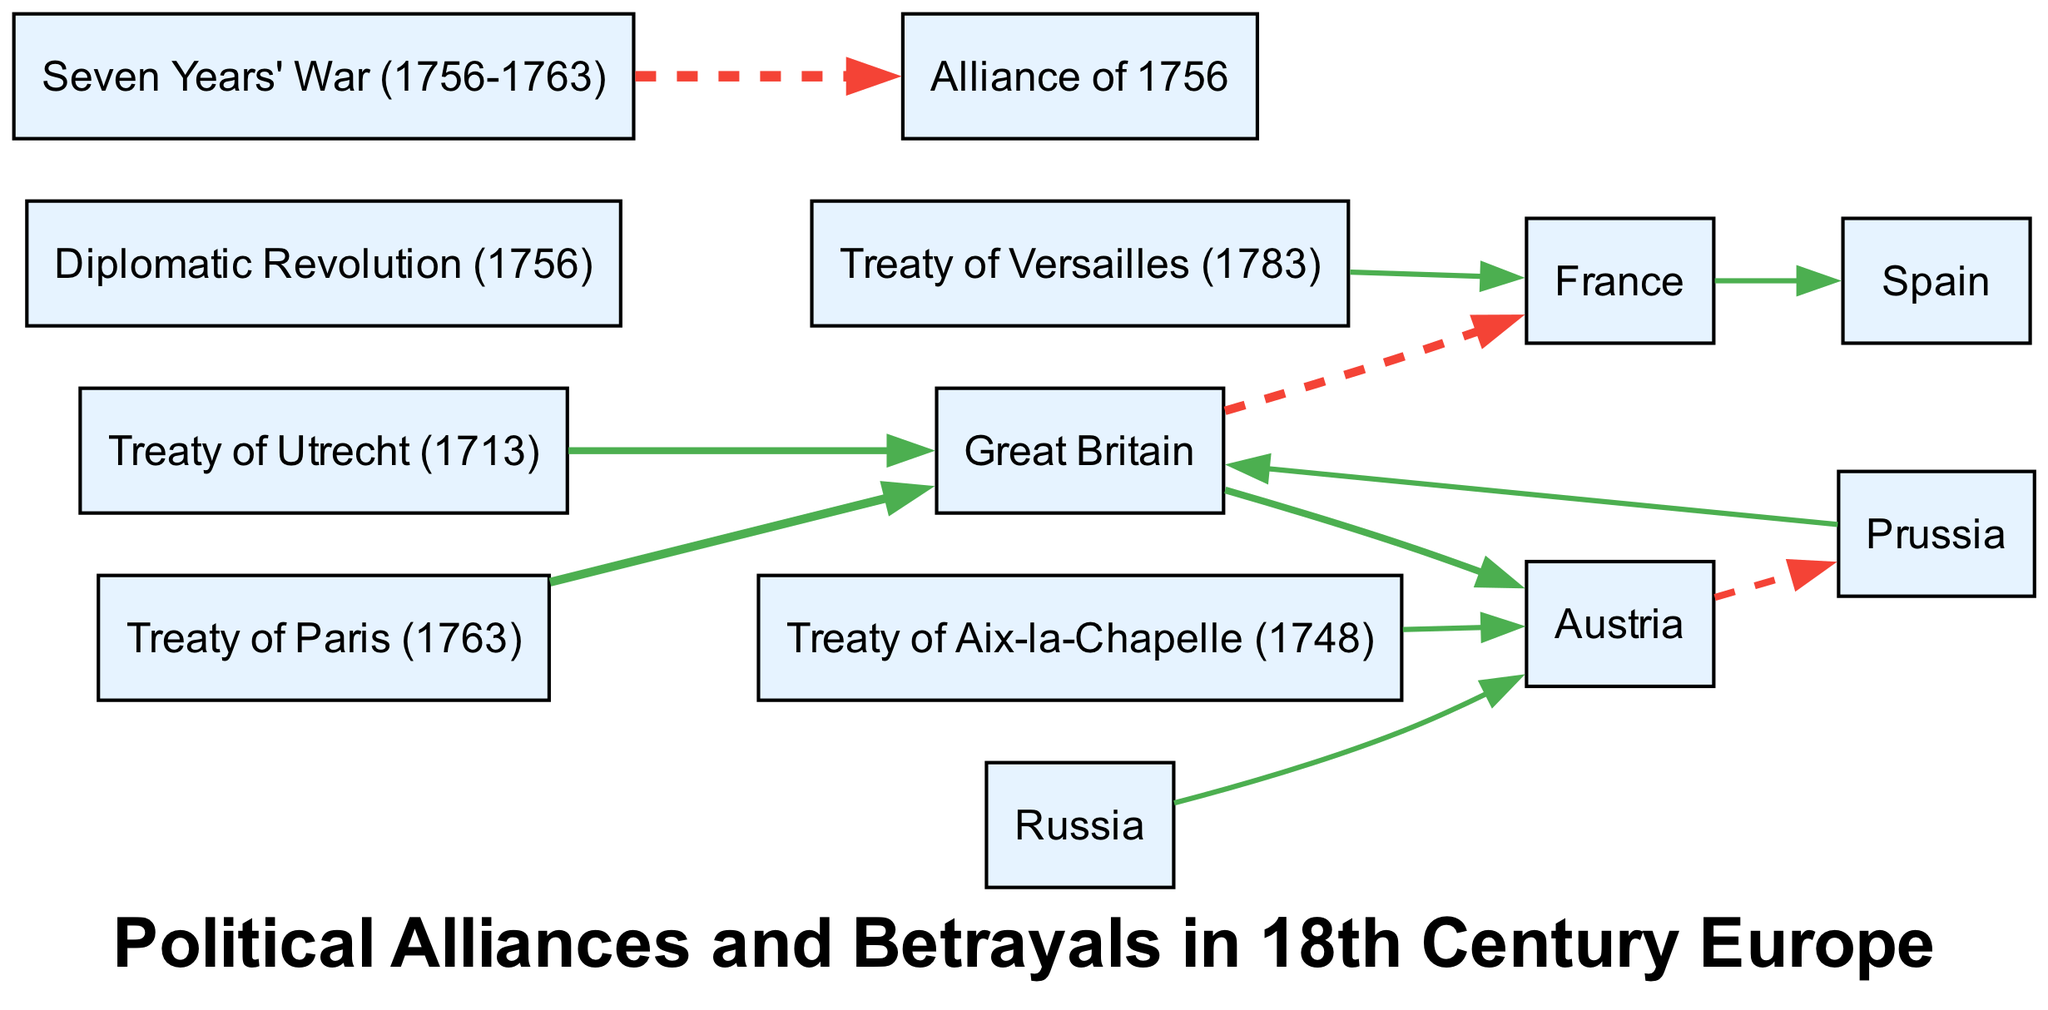What is the total number of nodes in the diagram? The diagram lists a total of 13 nodes, including countries and treaties. Each node represents a significant political entity or agreement, contributing to the overall structure of political alliances and betrayals in 18th Century Europe.
Answer: 13 Which country has a positive relationship with Great Britain? From the diagram, Great Britain has a positive relationship marked by a solid line with Austria, indicated by a value of 2. This represents an alliance or favorable relation between these two powers.
Answer: Austria What is the value of the relationship between France and Spain? The relationship between France and Spain is depicted with a value of 1, shown with a solid line. This indicates a positive yet weaker interaction (as opposed to stronger alliances) between these two nations during this period.
Answer: 1 Which treaty is associated with an increase in power for Great Britain? The Treaty of Paris (1763) is indicated as leading to an increase in power for Great Britain with a positive value of 3. This implies that the terms of the treaty were favorable to Great Britain, enhancing its influence in Europe.
Answer: Treaty of Paris (1763) How many alliances and betrayals are shown in the diagram? There are two types of relationships displayed: alliances (positive values) and betrayals (negative values). Counting the values, there are 6 alliances and 3 betrayals across the nodes.
Answer: 6 alliances, 3 betrayals What is the significance of the dashed line between the Seven Years' War and the Alliance of 1756? The dashed line represents a betrayal with a value of -4, suggesting that the outcome of the Seven Years' War significantly impacted the political dynamics negatively affecting the Alliance of 1756, illustrating a rupture or failure in the previously established alliance.
Answer: Betrayal Which countries are involved with the Treaty of Utrecht (1713)? The Treaty of Utrecht (1713) shows an interaction with Great Britain, where it has a positive value of 2. This treaty is historically significant as it marked the end of the War of Spanish Succession and established Great Britain’s presence as a significant power in Europe.
Answer: Great Britain What type of relationship does Prussia have with Great Britain? Prussia has a positive relationship with Great Britain, indicated by a solid line with a value of 1. This marks a mutual understanding or alliance, albeit a weaker one than its relationship with Austria.
Answer: Positive relationship Which treaty signifies a betrayal associated with Austria? The Alliance of 1756 reflects betrayal in the context of relationships formed and broken during the Seven Years' War, showcasing a significant shift in alliances impacting Austria. This indicates a negative outcome for Austria stemming from their alliances at that time.
Answer: Alliance of 1756 